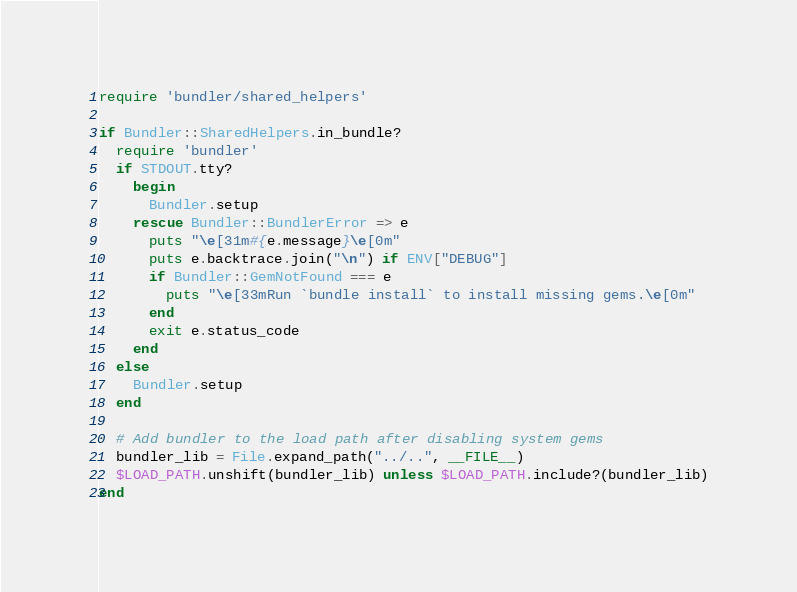<code> <loc_0><loc_0><loc_500><loc_500><_Ruby_>require 'bundler/shared_helpers'

if Bundler::SharedHelpers.in_bundle?
  require 'bundler'
  if STDOUT.tty?
    begin
      Bundler.setup
    rescue Bundler::BundlerError => e
      puts "\e[31m#{e.message}\e[0m"
      puts e.backtrace.join("\n") if ENV["DEBUG"]
      if Bundler::GemNotFound === e
        puts "\e[33mRun `bundle install` to install missing gems.\e[0m"
      end
      exit e.status_code
    end
  else
    Bundler.setup
  end

  # Add bundler to the load path after disabling system gems
  bundler_lib = File.expand_path("../..", __FILE__)
  $LOAD_PATH.unshift(bundler_lib) unless $LOAD_PATH.include?(bundler_lib)
end
</code> 